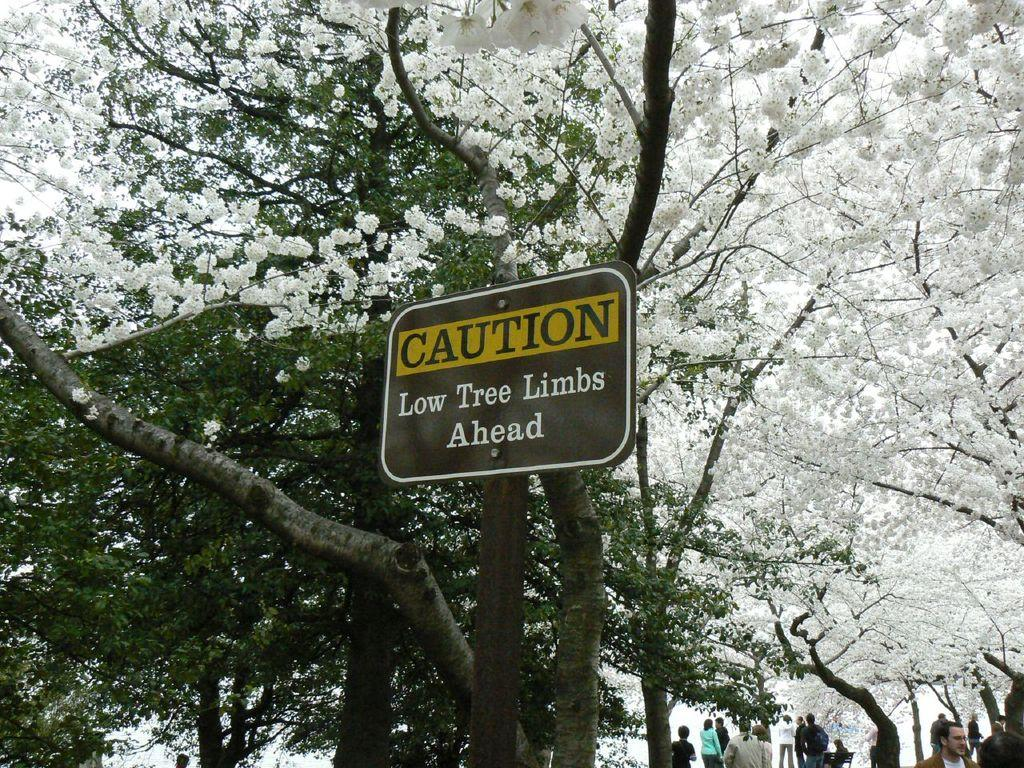How many people are in the image? There are people in the image, but the exact number is not specified. What is the position of one of the people in the image? There is a person sitting on a bench in the image. What can be seen in the background of the image? There are trees and a board in the image. What type of vegetation is present in the image? There are flowers in the image. What type of pot is being used to twist the authority in the image? There is no pot or authority mentioned in the image; it only features people, a bench, a board, trees, and flowers. 